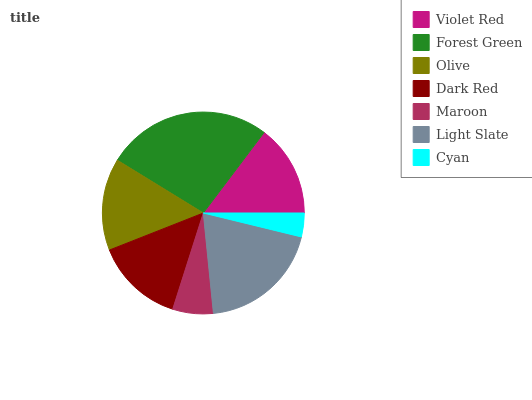Is Cyan the minimum?
Answer yes or no. Yes. Is Forest Green the maximum?
Answer yes or no. Yes. Is Olive the minimum?
Answer yes or no. No. Is Olive the maximum?
Answer yes or no. No. Is Forest Green greater than Olive?
Answer yes or no. Yes. Is Olive less than Forest Green?
Answer yes or no. Yes. Is Olive greater than Forest Green?
Answer yes or no. No. Is Forest Green less than Olive?
Answer yes or no. No. Is Violet Red the high median?
Answer yes or no. Yes. Is Violet Red the low median?
Answer yes or no. Yes. Is Olive the high median?
Answer yes or no. No. Is Dark Red the low median?
Answer yes or no. No. 